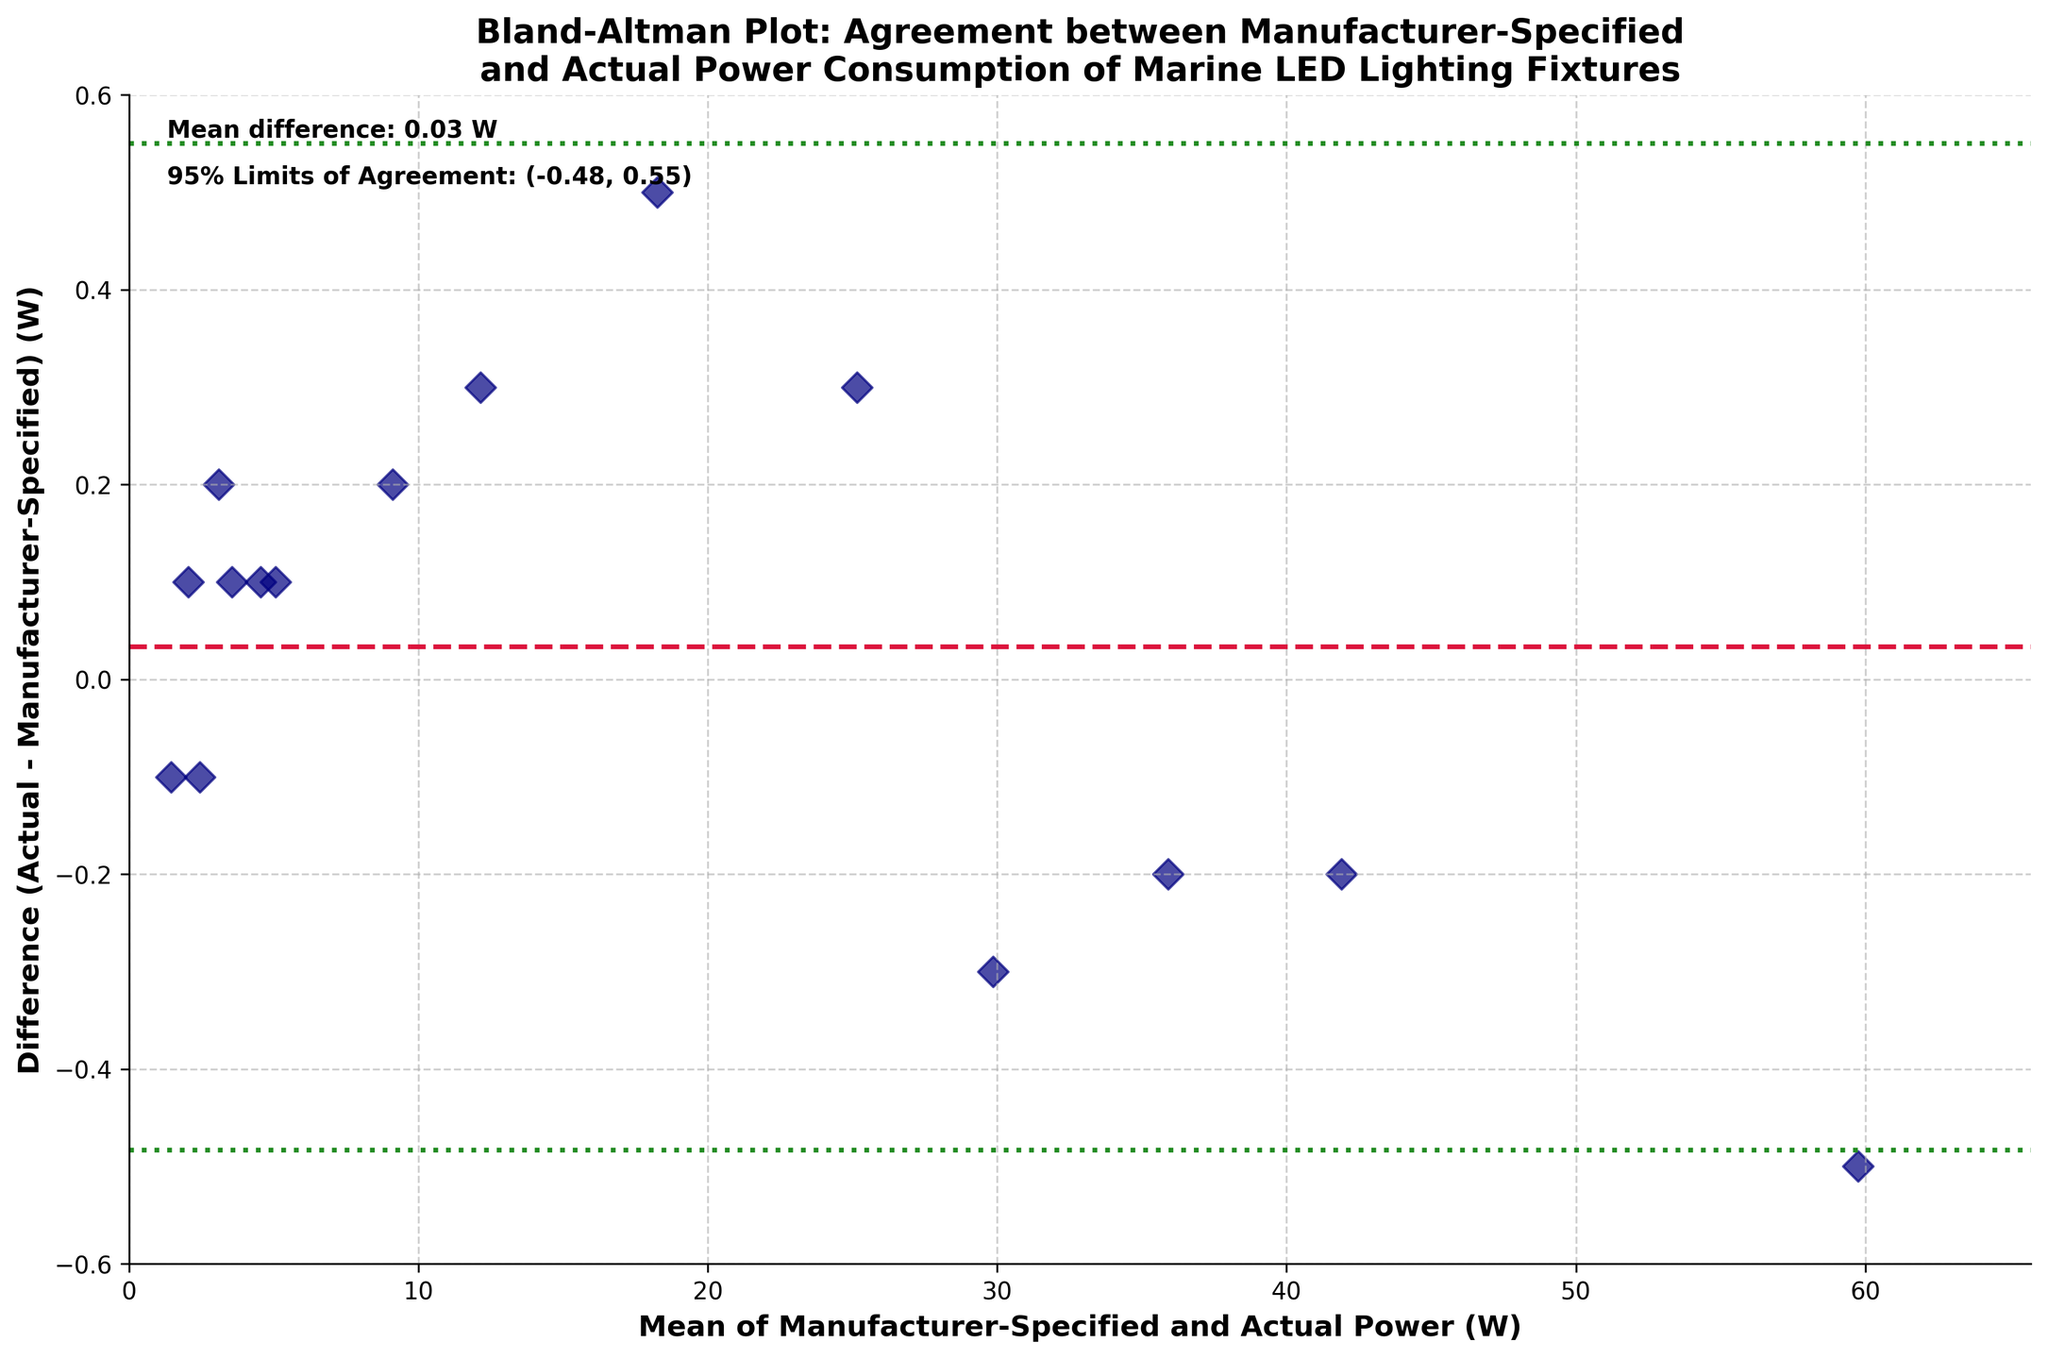What is the title of the plot? The title is typically at the top of the plot. Here, it reads "Bland-Altman Plot: Agreement between Manufacturer-Specified and Actual Power Consumption of Marine LED Lighting Fixtures," indicating the purpose of the plot and its context.
Answer: Bland-Altman Plot: Agreement between Manufacturer-Specified and Actual Power Consumption of Marine LED Lighting Fixtures What are the labels of the x-axis and y-axis? The x-axis and y-axis labels are positioned next to their respective axes. The x-axis label reads "Mean of Manufacturer-Specified and Actual Power (W)," and the y-axis label reads "Difference (Actual - Manufacturer-Specified) (W)."
Answer: Mean of Manufacturer-Specified and Actual Power (W); Difference (Actual - Manufacturer-Specified) (W) How many data points are displayed in the plot? Each data point represents a lighting fixture, plotted as diamonds on the graph. By counting these points, we see 15 data points, reflecting the number of fixtures in the dataset.
Answer: 15 What is the mean difference of the power consumption between manufacturer-specified and actual measurements? The mean difference is marked by a crimson dashed line across the plot, and its value is mentioned in the top left corner of the plot as a text annotation. It reads "Mean difference: 0.03 W."
Answer: 0.03 W What are the 95% limits of agreement for the difference in power consumption? The 95% limits of agreement are marked by forest-green dotted lines parallel to the mean difference line. The exact values are also provided in the top left annotation of the plot which reads, "95% Limits of Agreement: (-0.25, 0.31)."
Answer: (-0.25, 0.31) Which lighting fixture has the greatest actual measured power consumption? To determine this, identify the highest value on the x-axis, as this represents the mean of manufacturer-specified and actual power. The corresponding data point on the y-axis will show the actual measured power for this fixture. The highest value on the x-axis is for the Aqualuma Gen 4 Series Underwater Light.
Answer: Aqualuma Gen 4 Series Underwater Light Are there any devices for which the manufacturer-specified power is greater than the actual measured power? If so, how many? Devices where the manufacturer-specified power is greater will have their data points plotted below the zero line on the y-axis, indicating a negative difference. By counting these points, we see there are 3 such devices.
Answer: 3 What is the mean of manufacturer-specified and actual power for the lighting fixture with the largest positive difference? The largest positive difference can be found by identifying the highest point on the y-axis. The corresponding mean on the x-axis for this data point represents the mean of manufacturer-specified and actual power for that fixture. By observing the plot, the fixture is the Scanstrut ROKK Charge+ with a mean value close to 12.15 W.
Answer: 12.15 W What is the range of differences (Actual - Manufacturer-Specified) in the plot? The range can be determined by looking at the difference values on the y-axis. The minimum and maximum difference values on the plot are approximately -0.3 W to 0.3 W.
Answer: -0.3 W to 0.3 W 